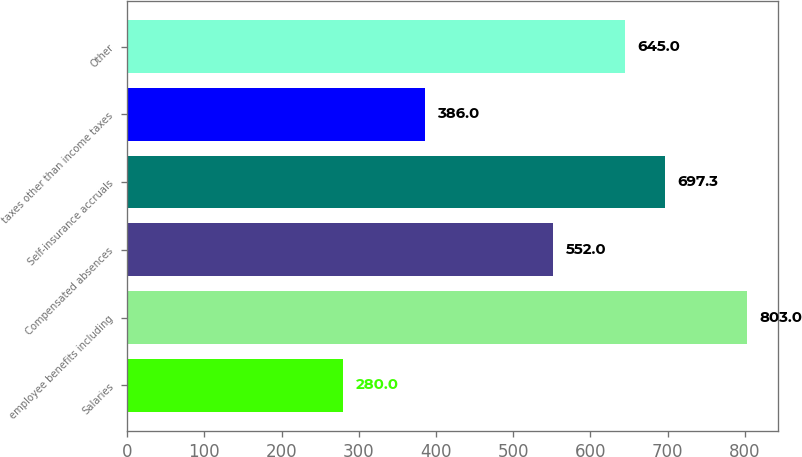<chart> <loc_0><loc_0><loc_500><loc_500><bar_chart><fcel>Salaries<fcel>employee benefits including<fcel>Compensated absences<fcel>Self-insurance accruals<fcel>taxes other than income taxes<fcel>Other<nl><fcel>280<fcel>803<fcel>552<fcel>697.3<fcel>386<fcel>645<nl></chart> 